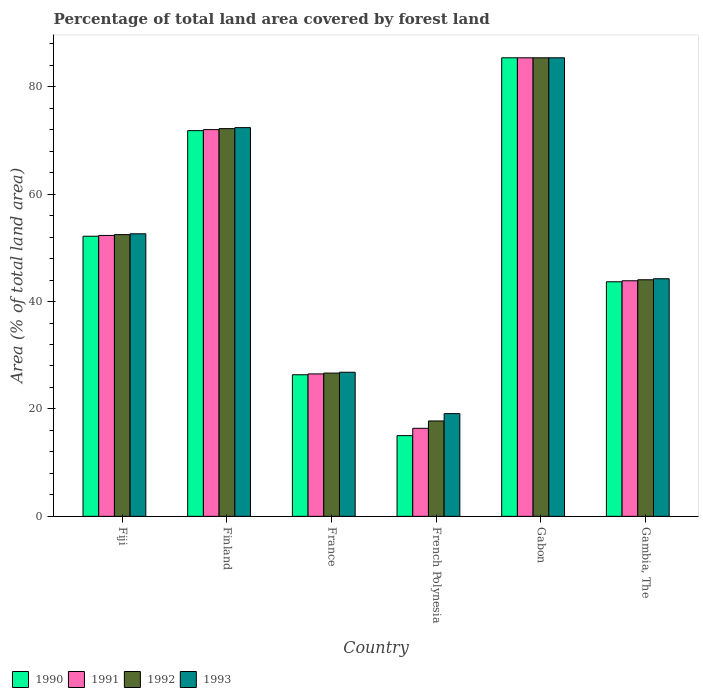How many groups of bars are there?
Keep it short and to the point. 6. Are the number of bars per tick equal to the number of legend labels?
Your answer should be very brief. Yes. Are the number of bars on each tick of the X-axis equal?
Offer a very short reply. Yes. How many bars are there on the 5th tick from the left?
Your response must be concise. 4. What is the label of the 1st group of bars from the left?
Make the answer very short. Fiji. What is the percentage of forest land in 1992 in Finland?
Your response must be concise. 72.19. Across all countries, what is the maximum percentage of forest land in 1993?
Your response must be concise. 85.38. Across all countries, what is the minimum percentage of forest land in 1990?
Your response must be concise. 15.03. In which country was the percentage of forest land in 1991 maximum?
Provide a short and direct response. Gabon. In which country was the percentage of forest land in 1993 minimum?
Make the answer very short. French Polynesia. What is the total percentage of forest land in 1991 in the graph?
Provide a short and direct response. 296.47. What is the difference between the percentage of forest land in 1993 in Finland and that in Gabon?
Offer a very short reply. -13. What is the difference between the percentage of forest land in 1992 in Gambia, The and the percentage of forest land in 1993 in Fiji?
Your answer should be compact. -8.56. What is the average percentage of forest land in 1990 per country?
Make the answer very short. 49.07. What is the difference between the percentage of forest land of/in 1993 and percentage of forest land of/in 1992 in Fiji?
Your answer should be very brief. 0.15. What is the ratio of the percentage of forest land in 1992 in Finland to that in French Polynesia?
Ensure brevity in your answer.  4.06. What is the difference between the highest and the second highest percentage of forest land in 1992?
Your response must be concise. 19.73. What is the difference between the highest and the lowest percentage of forest land in 1990?
Offer a terse response. 70.35. Is it the case that in every country, the sum of the percentage of forest land in 1990 and percentage of forest land in 1993 is greater than the sum of percentage of forest land in 1991 and percentage of forest land in 1992?
Provide a short and direct response. No. What does the 1st bar from the left in France represents?
Your response must be concise. 1990. What does the 4th bar from the right in Finland represents?
Ensure brevity in your answer.  1990. Is it the case that in every country, the sum of the percentage of forest land in 1993 and percentage of forest land in 1992 is greater than the percentage of forest land in 1990?
Ensure brevity in your answer.  Yes. How many bars are there?
Provide a succinct answer. 24. How many countries are there in the graph?
Provide a succinct answer. 6. Does the graph contain any zero values?
Offer a terse response. No. How many legend labels are there?
Your answer should be compact. 4. How are the legend labels stacked?
Provide a succinct answer. Horizontal. What is the title of the graph?
Your answer should be compact. Percentage of total land area covered by forest land. Does "1971" appear as one of the legend labels in the graph?
Your response must be concise. No. What is the label or title of the Y-axis?
Your response must be concise. Area (% of total land area). What is the Area (% of total land area) of 1990 in Fiji?
Your answer should be compact. 52.16. What is the Area (% of total land area) in 1991 in Fiji?
Your answer should be very brief. 52.31. What is the Area (% of total land area) in 1992 in Fiji?
Your response must be concise. 52.46. What is the Area (% of total land area) of 1993 in Fiji?
Provide a succinct answer. 52.61. What is the Area (% of total land area) in 1990 in Finland?
Your response must be concise. 71.82. What is the Area (% of total land area) in 1991 in Finland?
Your response must be concise. 72. What is the Area (% of total land area) in 1992 in Finland?
Provide a short and direct response. 72.19. What is the Area (% of total land area) of 1993 in Finland?
Your answer should be very brief. 72.38. What is the Area (% of total land area) of 1990 in France?
Give a very brief answer. 26.36. What is the Area (% of total land area) in 1991 in France?
Offer a terse response. 26.52. What is the Area (% of total land area) of 1992 in France?
Your answer should be compact. 26.68. What is the Area (% of total land area) in 1993 in France?
Provide a short and direct response. 26.83. What is the Area (% of total land area) of 1990 in French Polynesia?
Offer a very short reply. 15.03. What is the Area (% of total land area) in 1991 in French Polynesia?
Your answer should be very brief. 16.39. What is the Area (% of total land area) in 1992 in French Polynesia?
Ensure brevity in your answer.  17.76. What is the Area (% of total land area) of 1993 in French Polynesia?
Offer a terse response. 19.13. What is the Area (% of total land area) in 1990 in Gabon?
Give a very brief answer. 85.38. What is the Area (% of total land area) of 1991 in Gabon?
Offer a very short reply. 85.38. What is the Area (% of total land area) in 1992 in Gabon?
Give a very brief answer. 85.38. What is the Area (% of total land area) in 1993 in Gabon?
Ensure brevity in your answer.  85.38. What is the Area (% of total land area) in 1990 in Gambia, The?
Give a very brief answer. 43.68. What is the Area (% of total land area) of 1991 in Gambia, The?
Your answer should be very brief. 43.86. What is the Area (% of total land area) in 1992 in Gambia, The?
Ensure brevity in your answer.  44.05. What is the Area (% of total land area) of 1993 in Gambia, The?
Keep it short and to the point. 44.24. Across all countries, what is the maximum Area (% of total land area) in 1990?
Ensure brevity in your answer.  85.38. Across all countries, what is the maximum Area (% of total land area) of 1991?
Offer a very short reply. 85.38. Across all countries, what is the maximum Area (% of total land area) in 1992?
Keep it short and to the point. 85.38. Across all countries, what is the maximum Area (% of total land area) of 1993?
Your response must be concise. 85.38. Across all countries, what is the minimum Area (% of total land area) in 1990?
Ensure brevity in your answer.  15.03. Across all countries, what is the minimum Area (% of total land area) of 1991?
Give a very brief answer. 16.39. Across all countries, what is the minimum Area (% of total land area) in 1992?
Your response must be concise. 17.76. Across all countries, what is the minimum Area (% of total land area) in 1993?
Keep it short and to the point. 19.13. What is the total Area (% of total land area) in 1990 in the graph?
Provide a short and direct response. 294.42. What is the total Area (% of total land area) of 1991 in the graph?
Your answer should be compact. 296.47. What is the total Area (% of total land area) in 1992 in the graph?
Your answer should be compact. 298.52. What is the total Area (% of total land area) of 1993 in the graph?
Keep it short and to the point. 300.56. What is the difference between the Area (% of total land area) in 1990 in Fiji and that in Finland?
Your response must be concise. -19.66. What is the difference between the Area (% of total land area) in 1991 in Fiji and that in Finland?
Keep it short and to the point. -19.7. What is the difference between the Area (% of total land area) in 1992 in Fiji and that in Finland?
Your response must be concise. -19.73. What is the difference between the Area (% of total land area) of 1993 in Fiji and that in Finland?
Offer a very short reply. -19.77. What is the difference between the Area (% of total land area) in 1990 in Fiji and that in France?
Provide a succinct answer. 25.79. What is the difference between the Area (% of total land area) of 1991 in Fiji and that in France?
Offer a terse response. 25.79. What is the difference between the Area (% of total land area) in 1992 in Fiji and that in France?
Provide a succinct answer. 25.78. What is the difference between the Area (% of total land area) in 1993 in Fiji and that in France?
Your answer should be very brief. 25.78. What is the difference between the Area (% of total land area) of 1990 in Fiji and that in French Polynesia?
Make the answer very short. 37.13. What is the difference between the Area (% of total land area) in 1991 in Fiji and that in French Polynesia?
Offer a terse response. 35.91. What is the difference between the Area (% of total land area) in 1992 in Fiji and that in French Polynesia?
Make the answer very short. 34.7. What is the difference between the Area (% of total land area) in 1993 in Fiji and that in French Polynesia?
Ensure brevity in your answer.  33.48. What is the difference between the Area (% of total land area) in 1990 in Fiji and that in Gabon?
Offer a terse response. -33.22. What is the difference between the Area (% of total land area) in 1991 in Fiji and that in Gabon?
Ensure brevity in your answer.  -33.07. What is the difference between the Area (% of total land area) of 1992 in Fiji and that in Gabon?
Offer a terse response. -32.92. What is the difference between the Area (% of total land area) in 1993 in Fiji and that in Gabon?
Ensure brevity in your answer.  -32.77. What is the difference between the Area (% of total land area) in 1990 in Fiji and that in Gambia, The?
Ensure brevity in your answer.  8.48. What is the difference between the Area (% of total land area) in 1991 in Fiji and that in Gambia, The?
Give a very brief answer. 8.44. What is the difference between the Area (% of total land area) of 1992 in Fiji and that in Gambia, The?
Provide a short and direct response. 8.41. What is the difference between the Area (% of total land area) in 1993 in Fiji and that in Gambia, The?
Your answer should be compact. 8.37. What is the difference between the Area (% of total land area) in 1990 in Finland and that in France?
Your answer should be compact. 45.45. What is the difference between the Area (% of total land area) in 1991 in Finland and that in France?
Offer a terse response. 45.49. What is the difference between the Area (% of total land area) in 1992 in Finland and that in France?
Provide a succinct answer. 45.52. What is the difference between the Area (% of total land area) of 1993 in Finland and that in France?
Keep it short and to the point. 45.55. What is the difference between the Area (% of total land area) in 1990 in Finland and that in French Polynesia?
Offer a terse response. 56.79. What is the difference between the Area (% of total land area) in 1991 in Finland and that in French Polynesia?
Your answer should be compact. 55.61. What is the difference between the Area (% of total land area) of 1992 in Finland and that in French Polynesia?
Provide a succinct answer. 54.43. What is the difference between the Area (% of total land area) of 1993 in Finland and that in French Polynesia?
Offer a very short reply. 53.25. What is the difference between the Area (% of total land area) in 1990 in Finland and that in Gabon?
Your answer should be compact. -13.56. What is the difference between the Area (% of total land area) of 1991 in Finland and that in Gabon?
Make the answer very short. -13.38. What is the difference between the Area (% of total land area) of 1992 in Finland and that in Gabon?
Provide a short and direct response. -13.19. What is the difference between the Area (% of total land area) of 1993 in Finland and that in Gabon?
Keep it short and to the point. -13. What is the difference between the Area (% of total land area) of 1990 in Finland and that in Gambia, The?
Offer a very short reply. 28.14. What is the difference between the Area (% of total land area) of 1991 in Finland and that in Gambia, The?
Provide a short and direct response. 28.14. What is the difference between the Area (% of total land area) of 1992 in Finland and that in Gambia, The?
Your answer should be compact. 28.14. What is the difference between the Area (% of total land area) in 1993 in Finland and that in Gambia, The?
Keep it short and to the point. 28.14. What is the difference between the Area (% of total land area) of 1990 in France and that in French Polynesia?
Keep it short and to the point. 11.34. What is the difference between the Area (% of total land area) of 1991 in France and that in French Polynesia?
Offer a terse response. 10.13. What is the difference between the Area (% of total land area) of 1992 in France and that in French Polynesia?
Offer a very short reply. 8.92. What is the difference between the Area (% of total land area) in 1993 in France and that in French Polynesia?
Your answer should be very brief. 7.71. What is the difference between the Area (% of total land area) in 1990 in France and that in Gabon?
Provide a short and direct response. -59.02. What is the difference between the Area (% of total land area) of 1991 in France and that in Gabon?
Your answer should be compact. -58.86. What is the difference between the Area (% of total land area) of 1992 in France and that in Gabon?
Ensure brevity in your answer.  -58.7. What is the difference between the Area (% of total land area) in 1993 in France and that in Gabon?
Your answer should be compact. -58.55. What is the difference between the Area (% of total land area) of 1990 in France and that in Gambia, The?
Offer a very short reply. -17.31. What is the difference between the Area (% of total land area) in 1991 in France and that in Gambia, The?
Make the answer very short. -17.34. What is the difference between the Area (% of total land area) of 1992 in France and that in Gambia, The?
Your answer should be very brief. -17.38. What is the difference between the Area (% of total land area) in 1993 in France and that in Gambia, The?
Keep it short and to the point. -17.41. What is the difference between the Area (% of total land area) of 1990 in French Polynesia and that in Gabon?
Offer a terse response. -70.35. What is the difference between the Area (% of total land area) in 1991 in French Polynesia and that in Gabon?
Ensure brevity in your answer.  -68.99. What is the difference between the Area (% of total land area) of 1992 in French Polynesia and that in Gabon?
Keep it short and to the point. -67.62. What is the difference between the Area (% of total land area) in 1993 in French Polynesia and that in Gabon?
Your answer should be compact. -66.25. What is the difference between the Area (% of total land area) of 1990 in French Polynesia and that in Gambia, The?
Give a very brief answer. -28.65. What is the difference between the Area (% of total land area) in 1991 in French Polynesia and that in Gambia, The?
Provide a short and direct response. -27.47. What is the difference between the Area (% of total land area) of 1992 in French Polynesia and that in Gambia, The?
Your answer should be very brief. -26.29. What is the difference between the Area (% of total land area) of 1993 in French Polynesia and that in Gambia, The?
Your answer should be very brief. -25.11. What is the difference between the Area (% of total land area) of 1990 in Gabon and that in Gambia, The?
Ensure brevity in your answer.  41.7. What is the difference between the Area (% of total land area) of 1991 in Gabon and that in Gambia, The?
Give a very brief answer. 41.52. What is the difference between the Area (% of total land area) of 1992 in Gabon and that in Gambia, The?
Keep it short and to the point. 41.33. What is the difference between the Area (% of total land area) in 1993 in Gabon and that in Gambia, The?
Provide a short and direct response. 41.14. What is the difference between the Area (% of total land area) of 1990 in Fiji and the Area (% of total land area) of 1991 in Finland?
Offer a terse response. -19.85. What is the difference between the Area (% of total land area) of 1990 in Fiji and the Area (% of total land area) of 1992 in Finland?
Your answer should be very brief. -20.04. What is the difference between the Area (% of total land area) in 1990 in Fiji and the Area (% of total land area) in 1993 in Finland?
Ensure brevity in your answer.  -20.22. What is the difference between the Area (% of total land area) of 1991 in Fiji and the Area (% of total land area) of 1992 in Finland?
Offer a very short reply. -19.89. What is the difference between the Area (% of total land area) of 1991 in Fiji and the Area (% of total land area) of 1993 in Finland?
Keep it short and to the point. -20.07. What is the difference between the Area (% of total land area) in 1992 in Fiji and the Area (% of total land area) in 1993 in Finland?
Give a very brief answer. -19.92. What is the difference between the Area (% of total land area) in 1990 in Fiji and the Area (% of total land area) in 1991 in France?
Offer a very short reply. 25.64. What is the difference between the Area (% of total land area) in 1990 in Fiji and the Area (% of total land area) in 1992 in France?
Ensure brevity in your answer.  25.48. What is the difference between the Area (% of total land area) of 1990 in Fiji and the Area (% of total land area) of 1993 in France?
Your answer should be very brief. 25.33. What is the difference between the Area (% of total land area) in 1991 in Fiji and the Area (% of total land area) in 1992 in France?
Make the answer very short. 25.63. What is the difference between the Area (% of total land area) in 1991 in Fiji and the Area (% of total land area) in 1993 in France?
Offer a very short reply. 25.48. What is the difference between the Area (% of total land area) of 1992 in Fiji and the Area (% of total land area) of 1993 in France?
Your response must be concise. 25.63. What is the difference between the Area (% of total land area) in 1990 in Fiji and the Area (% of total land area) in 1991 in French Polynesia?
Your answer should be very brief. 35.76. What is the difference between the Area (% of total land area) in 1990 in Fiji and the Area (% of total land area) in 1992 in French Polynesia?
Your answer should be very brief. 34.4. What is the difference between the Area (% of total land area) in 1990 in Fiji and the Area (% of total land area) in 1993 in French Polynesia?
Offer a very short reply. 33.03. What is the difference between the Area (% of total land area) in 1991 in Fiji and the Area (% of total land area) in 1992 in French Polynesia?
Offer a terse response. 34.55. What is the difference between the Area (% of total land area) in 1991 in Fiji and the Area (% of total land area) in 1993 in French Polynesia?
Your answer should be compact. 33.18. What is the difference between the Area (% of total land area) of 1992 in Fiji and the Area (% of total land area) of 1993 in French Polynesia?
Offer a terse response. 33.33. What is the difference between the Area (% of total land area) in 1990 in Fiji and the Area (% of total land area) in 1991 in Gabon?
Your response must be concise. -33.22. What is the difference between the Area (% of total land area) of 1990 in Fiji and the Area (% of total land area) of 1992 in Gabon?
Provide a short and direct response. -33.22. What is the difference between the Area (% of total land area) of 1990 in Fiji and the Area (% of total land area) of 1993 in Gabon?
Ensure brevity in your answer.  -33.22. What is the difference between the Area (% of total land area) in 1991 in Fiji and the Area (% of total land area) in 1992 in Gabon?
Provide a short and direct response. -33.07. What is the difference between the Area (% of total land area) in 1991 in Fiji and the Area (% of total land area) in 1993 in Gabon?
Make the answer very short. -33.07. What is the difference between the Area (% of total land area) in 1992 in Fiji and the Area (% of total land area) in 1993 in Gabon?
Your answer should be compact. -32.92. What is the difference between the Area (% of total land area) in 1990 in Fiji and the Area (% of total land area) in 1991 in Gambia, The?
Keep it short and to the point. 8.29. What is the difference between the Area (% of total land area) of 1990 in Fiji and the Area (% of total land area) of 1992 in Gambia, The?
Make the answer very short. 8.11. What is the difference between the Area (% of total land area) in 1990 in Fiji and the Area (% of total land area) in 1993 in Gambia, The?
Ensure brevity in your answer.  7.92. What is the difference between the Area (% of total land area) of 1991 in Fiji and the Area (% of total land area) of 1992 in Gambia, The?
Offer a terse response. 8.26. What is the difference between the Area (% of total land area) in 1991 in Fiji and the Area (% of total land area) in 1993 in Gambia, The?
Make the answer very short. 8.07. What is the difference between the Area (% of total land area) of 1992 in Fiji and the Area (% of total land area) of 1993 in Gambia, The?
Offer a very short reply. 8.22. What is the difference between the Area (% of total land area) of 1990 in Finland and the Area (% of total land area) of 1991 in France?
Offer a very short reply. 45.3. What is the difference between the Area (% of total land area) in 1990 in Finland and the Area (% of total land area) in 1992 in France?
Give a very brief answer. 45.14. What is the difference between the Area (% of total land area) in 1990 in Finland and the Area (% of total land area) in 1993 in France?
Give a very brief answer. 44.99. What is the difference between the Area (% of total land area) in 1991 in Finland and the Area (% of total land area) in 1992 in France?
Provide a short and direct response. 45.33. What is the difference between the Area (% of total land area) in 1991 in Finland and the Area (% of total land area) in 1993 in France?
Your answer should be compact. 45.17. What is the difference between the Area (% of total land area) in 1992 in Finland and the Area (% of total land area) in 1993 in France?
Offer a very short reply. 45.36. What is the difference between the Area (% of total land area) in 1990 in Finland and the Area (% of total land area) in 1991 in French Polynesia?
Ensure brevity in your answer.  55.42. What is the difference between the Area (% of total land area) of 1990 in Finland and the Area (% of total land area) of 1992 in French Polynesia?
Your answer should be compact. 54.06. What is the difference between the Area (% of total land area) in 1990 in Finland and the Area (% of total land area) in 1993 in French Polynesia?
Give a very brief answer. 52.69. What is the difference between the Area (% of total land area) in 1991 in Finland and the Area (% of total land area) in 1992 in French Polynesia?
Ensure brevity in your answer.  54.25. What is the difference between the Area (% of total land area) in 1991 in Finland and the Area (% of total land area) in 1993 in French Polynesia?
Ensure brevity in your answer.  52.88. What is the difference between the Area (% of total land area) in 1992 in Finland and the Area (% of total land area) in 1993 in French Polynesia?
Provide a short and direct response. 53.07. What is the difference between the Area (% of total land area) in 1990 in Finland and the Area (% of total land area) in 1991 in Gabon?
Your response must be concise. -13.56. What is the difference between the Area (% of total land area) in 1990 in Finland and the Area (% of total land area) in 1992 in Gabon?
Ensure brevity in your answer.  -13.56. What is the difference between the Area (% of total land area) in 1990 in Finland and the Area (% of total land area) in 1993 in Gabon?
Provide a succinct answer. -13.56. What is the difference between the Area (% of total land area) in 1991 in Finland and the Area (% of total land area) in 1992 in Gabon?
Offer a very short reply. -13.38. What is the difference between the Area (% of total land area) in 1991 in Finland and the Area (% of total land area) in 1993 in Gabon?
Ensure brevity in your answer.  -13.38. What is the difference between the Area (% of total land area) of 1992 in Finland and the Area (% of total land area) of 1993 in Gabon?
Offer a terse response. -13.19. What is the difference between the Area (% of total land area) of 1990 in Finland and the Area (% of total land area) of 1991 in Gambia, The?
Your response must be concise. 27.95. What is the difference between the Area (% of total land area) in 1990 in Finland and the Area (% of total land area) in 1992 in Gambia, The?
Offer a very short reply. 27.77. What is the difference between the Area (% of total land area) of 1990 in Finland and the Area (% of total land area) of 1993 in Gambia, The?
Provide a succinct answer. 27.58. What is the difference between the Area (% of total land area) in 1991 in Finland and the Area (% of total land area) in 1992 in Gambia, The?
Your answer should be compact. 27.95. What is the difference between the Area (% of total land area) in 1991 in Finland and the Area (% of total land area) in 1993 in Gambia, The?
Make the answer very short. 27.77. What is the difference between the Area (% of total land area) in 1992 in Finland and the Area (% of total land area) in 1993 in Gambia, The?
Provide a succinct answer. 27.95. What is the difference between the Area (% of total land area) of 1990 in France and the Area (% of total land area) of 1991 in French Polynesia?
Provide a short and direct response. 9.97. What is the difference between the Area (% of total land area) in 1990 in France and the Area (% of total land area) in 1992 in French Polynesia?
Ensure brevity in your answer.  8.6. What is the difference between the Area (% of total land area) in 1990 in France and the Area (% of total land area) in 1993 in French Polynesia?
Keep it short and to the point. 7.24. What is the difference between the Area (% of total land area) in 1991 in France and the Area (% of total land area) in 1992 in French Polynesia?
Your answer should be compact. 8.76. What is the difference between the Area (% of total land area) of 1991 in France and the Area (% of total land area) of 1993 in French Polynesia?
Your answer should be compact. 7.39. What is the difference between the Area (% of total land area) in 1992 in France and the Area (% of total land area) in 1993 in French Polynesia?
Offer a very short reply. 7.55. What is the difference between the Area (% of total land area) in 1990 in France and the Area (% of total land area) in 1991 in Gabon?
Make the answer very short. -59.02. What is the difference between the Area (% of total land area) of 1990 in France and the Area (% of total land area) of 1992 in Gabon?
Your answer should be very brief. -59.02. What is the difference between the Area (% of total land area) of 1990 in France and the Area (% of total land area) of 1993 in Gabon?
Provide a short and direct response. -59.02. What is the difference between the Area (% of total land area) of 1991 in France and the Area (% of total land area) of 1992 in Gabon?
Provide a short and direct response. -58.86. What is the difference between the Area (% of total land area) of 1991 in France and the Area (% of total land area) of 1993 in Gabon?
Offer a very short reply. -58.86. What is the difference between the Area (% of total land area) of 1992 in France and the Area (% of total land area) of 1993 in Gabon?
Make the answer very short. -58.7. What is the difference between the Area (% of total land area) of 1990 in France and the Area (% of total land area) of 1991 in Gambia, The?
Offer a terse response. -17.5. What is the difference between the Area (% of total land area) in 1990 in France and the Area (% of total land area) in 1992 in Gambia, The?
Your answer should be compact. -17.69. What is the difference between the Area (% of total land area) of 1990 in France and the Area (% of total land area) of 1993 in Gambia, The?
Give a very brief answer. -17.88. What is the difference between the Area (% of total land area) in 1991 in France and the Area (% of total land area) in 1992 in Gambia, The?
Ensure brevity in your answer.  -17.53. What is the difference between the Area (% of total land area) in 1991 in France and the Area (% of total land area) in 1993 in Gambia, The?
Offer a terse response. -17.72. What is the difference between the Area (% of total land area) of 1992 in France and the Area (% of total land area) of 1993 in Gambia, The?
Your answer should be compact. -17.56. What is the difference between the Area (% of total land area) in 1990 in French Polynesia and the Area (% of total land area) in 1991 in Gabon?
Offer a very short reply. -70.35. What is the difference between the Area (% of total land area) in 1990 in French Polynesia and the Area (% of total land area) in 1992 in Gabon?
Your answer should be compact. -70.35. What is the difference between the Area (% of total land area) of 1990 in French Polynesia and the Area (% of total land area) of 1993 in Gabon?
Your response must be concise. -70.35. What is the difference between the Area (% of total land area) in 1991 in French Polynesia and the Area (% of total land area) in 1992 in Gabon?
Give a very brief answer. -68.99. What is the difference between the Area (% of total land area) of 1991 in French Polynesia and the Area (% of total land area) of 1993 in Gabon?
Your answer should be very brief. -68.99. What is the difference between the Area (% of total land area) of 1992 in French Polynesia and the Area (% of total land area) of 1993 in Gabon?
Give a very brief answer. -67.62. What is the difference between the Area (% of total land area) of 1990 in French Polynesia and the Area (% of total land area) of 1991 in Gambia, The?
Ensure brevity in your answer.  -28.84. What is the difference between the Area (% of total land area) in 1990 in French Polynesia and the Area (% of total land area) in 1992 in Gambia, The?
Offer a terse response. -29.02. What is the difference between the Area (% of total land area) of 1990 in French Polynesia and the Area (% of total land area) of 1993 in Gambia, The?
Provide a short and direct response. -29.21. What is the difference between the Area (% of total land area) in 1991 in French Polynesia and the Area (% of total land area) in 1992 in Gambia, The?
Provide a succinct answer. -27.66. What is the difference between the Area (% of total land area) in 1991 in French Polynesia and the Area (% of total land area) in 1993 in Gambia, The?
Your response must be concise. -27.85. What is the difference between the Area (% of total land area) of 1992 in French Polynesia and the Area (% of total land area) of 1993 in Gambia, The?
Keep it short and to the point. -26.48. What is the difference between the Area (% of total land area) in 1990 in Gabon and the Area (% of total land area) in 1991 in Gambia, The?
Your answer should be very brief. 41.52. What is the difference between the Area (% of total land area) in 1990 in Gabon and the Area (% of total land area) in 1992 in Gambia, The?
Ensure brevity in your answer.  41.33. What is the difference between the Area (% of total land area) in 1990 in Gabon and the Area (% of total land area) in 1993 in Gambia, The?
Ensure brevity in your answer.  41.14. What is the difference between the Area (% of total land area) in 1991 in Gabon and the Area (% of total land area) in 1992 in Gambia, The?
Ensure brevity in your answer.  41.33. What is the difference between the Area (% of total land area) in 1991 in Gabon and the Area (% of total land area) in 1993 in Gambia, The?
Your answer should be very brief. 41.14. What is the difference between the Area (% of total land area) of 1992 in Gabon and the Area (% of total land area) of 1993 in Gambia, The?
Keep it short and to the point. 41.14. What is the average Area (% of total land area) of 1990 per country?
Ensure brevity in your answer.  49.07. What is the average Area (% of total land area) in 1991 per country?
Offer a terse response. 49.41. What is the average Area (% of total land area) of 1992 per country?
Your answer should be very brief. 49.75. What is the average Area (% of total land area) of 1993 per country?
Your response must be concise. 50.09. What is the difference between the Area (% of total land area) of 1990 and Area (% of total land area) of 1991 in Fiji?
Ensure brevity in your answer.  -0.15. What is the difference between the Area (% of total land area) in 1990 and Area (% of total land area) in 1992 in Fiji?
Ensure brevity in your answer.  -0.3. What is the difference between the Area (% of total land area) in 1990 and Area (% of total land area) in 1993 in Fiji?
Make the answer very short. -0.45. What is the difference between the Area (% of total land area) of 1991 and Area (% of total land area) of 1992 in Fiji?
Make the answer very short. -0.15. What is the difference between the Area (% of total land area) of 1991 and Area (% of total land area) of 1993 in Fiji?
Keep it short and to the point. -0.3. What is the difference between the Area (% of total land area) of 1992 and Area (% of total land area) of 1993 in Fiji?
Your answer should be compact. -0.15. What is the difference between the Area (% of total land area) in 1990 and Area (% of total land area) in 1991 in Finland?
Give a very brief answer. -0.19. What is the difference between the Area (% of total land area) of 1990 and Area (% of total land area) of 1992 in Finland?
Provide a short and direct response. -0.37. What is the difference between the Area (% of total land area) in 1990 and Area (% of total land area) in 1993 in Finland?
Provide a succinct answer. -0.56. What is the difference between the Area (% of total land area) in 1991 and Area (% of total land area) in 1992 in Finland?
Your response must be concise. -0.19. What is the difference between the Area (% of total land area) of 1991 and Area (% of total land area) of 1993 in Finland?
Offer a terse response. -0.37. What is the difference between the Area (% of total land area) in 1992 and Area (% of total land area) in 1993 in Finland?
Provide a short and direct response. -0.19. What is the difference between the Area (% of total land area) of 1990 and Area (% of total land area) of 1991 in France?
Your answer should be very brief. -0.16. What is the difference between the Area (% of total land area) in 1990 and Area (% of total land area) in 1992 in France?
Offer a very short reply. -0.31. What is the difference between the Area (% of total land area) in 1990 and Area (% of total land area) in 1993 in France?
Your answer should be very brief. -0.47. What is the difference between the Area (% of total land area) of 1991 and Area (% of total land area) of 1992 in France?
Your answer should be very brief. -0.16. What is the difference between the Area (% of total land area) of 1991 and Area (% of total land area) of 1993 in France?
Your answer should be compact. -0.31. What is the difference between the Area (% of total land area) in 1992 and Area (% of total land area) in 1993 in France?
Your answer should be very brief. -0.16. What is the difference between the Area (% of total land area) in 1990 and Area (% of total land area) in 1991 in French Polynesia?
Ensure brevity in your answer.  -1.37. What is the difference between the Area (% of total land area) of 1990 and Area (% of total land area) of 1992 in French Polynesia?
Your response must be concise. -2.73. What is the difference between the Area (% of total land area) of 1990 and Area (% of total land area) of 1993 in French Polynesia?
Your answer should be very brief. -4.1. What is the difference between the Area (% of total land area) of 1991 and Area (% of total land area) of 1992 in French Polynesia?
Your response must be concise. -1.37. What is the difference between the Area (% of total land area) of 1991 and Area (% of total land area) of 1993 in French Polynesia?
Your response must be concise. -2.73. What is the difference between the Area (% of total land area) in 1992 and Area (% of total land area) in 1993 in French Polynesia?
Give a very brief answer. -1.37. What is the difference between the Area (% of total land area) of 1990 and Area (% of total land area) of 1991 in Gabon?
Make the answer very short. 0. What is the difference between the Area (% of total land area) in 1990 and Area (% of total land area) in 1993 in Gabon?
Give a very brief answer. 0. What is the difference between the Area (% of total land area) in 1991 and Area (% of total land area) in 1992 in Gabon?
Make the answer very short. 0. What is the difference between the Area (% of total land area) in 1991 and Area (% of total land area) in 1993 in Gabon?
Keep it short and to the point. 0. What is the difference between the Area (% of total land area) in 1990 and Area (% of total land area) in 1991 in Gambia, The?
Make the answer very short. -0.19. What is the difference between the Area (% of total land area) of 1990 and Area (% of total land area) of 1992 in Gambia, The?
Keep it short and to the point. -0.38. What is the difference between the Area (% of total land area) in 1990 and Area (% of total land area) in 1993 in Gambia, The?
Provide a short and direct response. -0.56. What is the difference between the Area (% of total land area) of 1991 and Area (% of total land area) of 1992 in Gambia, The?
Keep it short and to the point. -0.19. What is the difference between the Area (% of total land area) in 1991 and Area (% of total land area) in 1993 in Gambia, The?
Give a very brief answer. -0.38. What is the difference between the Area (% of total land area) of 1992 and Area (% of total land area) of 1993 in Gambia, The?
Your answer should be compact. -0.19. What is the ratio of the Area (% of total land area) in 1990 in Fiji to that in Finland?
Offer a terse response. 0.73. What is the ratio of the Area (% of total land area) of 1991 in Fiji to that in Finland?
Offer a very short reply. 0.73. What is the ratio of the Area (% of total land area) of 1992 in Fiji to that in Finland?
Make the answer very short. 0.73. What is the ratio of the Area (% of total land area) in 1993 in Fiji to that in Finland?
Ensure brevity in your answer.  0.73. What is the ratio of the Area (% of total land area) of 1990 in Fiji to that in France?
Offer a terse response. 1.98. What is the ratio of the Area (% of total land area) in 1991 in Fiji to that in France?
Ensure brevity in your answer.  1.97. What is the ratio of the Area (% of total land area) of 1992 in Fiji to that in France?
Keep it short and to the point. 1.97. What is the ratio of the Area (% of total land area) of 1993 in Fiji to that in France?
Your answer should be very brief. 1.96. What is the ratio of the Area (% of total land area) in 1990 in Fiji to that in French Polynesia?
Give a very brief answer. 3.47. What is the ratio of the Area (% of total land area) in 1991 in Fiji to that in French Polynesia?
Provide a succinct answer. 3.19. What is the ratio of the Area (% of total land area) of 1992 in Fiji to that in French Polynesia?
Provide a short and direct response. 2.95. What is the ratio of the Area (% of total land area) in 1993 in Fiji to that in French Polynesia?
Your answer should be very brief. 2.75. What is the ratio of the Area (% of total land area) of 1990 in Fiji to that in Gabon?
Your response must be concise. 0.61. What is the ratio of the Area (% of total land area) in 1991 in Fiji to that in Gabon?
Your answer should be compact. 0.61. What is the ratio of the Area (% of total land area) in 1992 in Fiji to that in Gabon?
Provide a short and direct response. 0.61. What is the ratio of the Area (% of total land area) in 1993 in Fiji to that in Gabon?
Offer a terse response. 0.62. What is the ratio of the Area (% of total land area) of 1990 in Fiji to that in Gambia, The?
Provide a short and direct response. 1.19. What is the ratio of the Area (% of total land area) in 1991 in Fiji to that in Gambia, The?
Offer a very short reply. 1.19. What is the ratio of the Area (% of total land area) of 1992 in Fiji to that in Gambia, The?
Provide a short and direct response. 1.19. What is the ratio of the Area (% of total land area) in 1993 in Fiji to that in Gambia, The?
Provide a short and direct response. 1.19. What is the ratio of the Area (% of total land area) of 1990 in Finland to that in France?
Offer a terse response. 2.72. What is the ratio of the Area (% of total land area) of 1991 in Finland to that in France?
Provide a succinct answer. 2.72. What is the ratio of the Area (% of total land area) of 1992 in Finland to that in France?
Offer a very short reply. 2.71. What is the ratio of the Area (% of total land area) in 1993 in Finland to that in France?
Give a very brief answer. 2.7. What is the ratio of the Area (% of total land area) of 1990 in Finland to that in French Polynesia?
Your response must be concise. 4.78. What is the ratio of the Area (% of total land area) of 1991 in Finland to that in French Polynesia?
Offer a terse response. 4.39. What is the ratio of the Area (% of total land area) in 1992 in Finland to that in French Polynesia?
Make the answer very short. 4.07. What is the ratio of the Area (% of total land area) in 1993 in Finland to that in French Polynesia?
Make the answer very short. 3.78. What is the ratio of the Area (% of total land area) of 1990 in Finland to that in Gabon?
Your answer should be compact. 0.84. What is the ratio of the Area (% of total land area) of 1991 in Finland to that in Gabon?
Provide a short and direct response. 0.84. What is the ratio of the Area (% of total land area) of 1992 in Finland to that in Gabon?
Offer a terse response. 0.85. What is the ratio of the Area (% of total land area) in 1993 in Finland to that in Gabon?
Ensure brevity in your answer.  0.85. What is the ratio of the Area (% of total land area) in 1990 in Finland to that in Gambia, The?
Provide a succinct answer. 1.64. What is the ratio of the Area (% of total land area) in 1991 in Finland to that in Gambia, The?
Provide a short and direct response. 1.64. What is the ratio of the Area (% of total land area) in 1992 in Finland to that in Gambia, The?
Your answer should be compact. 1.64. What is the ratio of the Area (% of total land area) in 1993 in Finland to that in Gambia, The?
Provide a succinct answer. 1.64. What is the ratio of the Area (% of total land area) of 1990 in France to that in French Polynesia?
Provide a succinct answer. 1.75. What is the ratio of the Area (% of total land area) of 1991 in France to that in French Polynesia?
Provide a succinct answer. 1.62. What is the ratio of the Area (% of total land area) in 1992 in France to that in French Polynesia?
Keep it short and to the point. 1.5. What is the ratio of the Area (% of total land area) of 1993 in France to that in French Polynesia?
Offer a very short reply. 1.4. What is the ratio of the Area (% of total land area) of 1990 in France to that in Gabon?
Offer a terse response. 0.31. What is the ratio of the Area (% of total land area) in 1991 in France to that in Gabon?
Give a very brief answer. 0.31. What is the ratio of the Area (% of total land area) in 1992 in France to that in Gabon?
Your answer should be very brief. 0.31. What is the ratio of the Area (% of total land area) in 1993 in France to that in Gabon?
Keep it short and to the point. 0.31. What is the ratio of the Area (% of total land area) in 1990 in France to that in Gambia, The?
Offer a terse response. 0.6. What is the ratio of the Area (% of total land area) of 1991 in France to that in Gambia, The?
Ensure brevity in your answer.  0.6. What is the ratio of the Area (% of total land area) in 1992 in France to that in Gambia, The?
Ensure brevity in your answer.  0.61. What is the ratio of the Area (% of total land area) of 1993 in France to that in Gambia, The?
Your answer should be compact. 0.61. What is the ratio of the Area (% of total land area) in 1990 in French Polynesia to that in Gabon?
Provide a short and direct response. 0.18. What is the ratio of the Area (% of total land area) of 1991 in French Polynesia to that in Gabon?
Offer a terse response. 0.19. What is the ratio of the Area (% of total land area) in 1992 in French Polynesia to that in Gabon?
Provide a succinct answer. 0.21. What is the ratio of the Area (% of total land area) of 1993 in French Polynesia to that in Gabon?
Make the answer very short. 0.22. What is the ratio of the Area (% of total land area) of 1990 in French Polynesia to that in Gambia, The?
Offer a terse response. 0.34. What is the ratio of the Area (% of total land area) of 1991 in French Polynesia to that in Gambia, The?
Ensure brevity in your answer.  0.37. What is the ratio of the Area (% of total land area) of 1992 in French Polynesia to that in Gambia, The?
Your response must be concise. 0.4. What is the ratio of the Area (% of total land area) in 1993 in French Polynesia to that in Gambia, The?
Offer a terse response. 0.43. What is the ratio of the Area (% of total land area) of 1990 in Gabon to that in Gambia, The?
Make the answer very short. 1.95. What is the ratio of the Area (% of total land area) of 1991 in Gabon to that in Gambia, The?
Provide a succinct answer. 1.95. What is the ratio of the Area (% of total land area) in 1992 in Gabon to that in Gambia, The?
Your answer should be very brief. 1.94. What is the ratio of the Area (% of total land area) in 1993 in Gabon to that in Gambia, The?
Keep it short and to the point. 1.93. What is the difference between the highest and the second highest Area (% of total land area) in 1990?
Ensure brevity in your answer.  13.56. What is the difference between the highest and the second highest Area (% of total land area) in 1991?
Offer a very short reply. 13.38. What is the difference between the highest and the second highest Area (% of total land area) in 1992?
Your answer should be very brief. 13.19. What is the difference between the highest and the second highest Area (% of total land area) in 1993?
Keep it short and to the point. 13. What is the difference between the highest and the lowest Area (% of total land area) of 1990?
Offer a terse response. 70.35. What is the difference between the highest and the lowest Area (% of total land area) in 1991?
Offer a very short reply. 68.99. What is the difference between the highest and the lowest Area (% of total land area) in 1992?
Provide a succinct answer. 67.62. What is the difference between the highest and the lowest Area (% of total land area) in 1993?
Give a very brief answer. 66.25. 